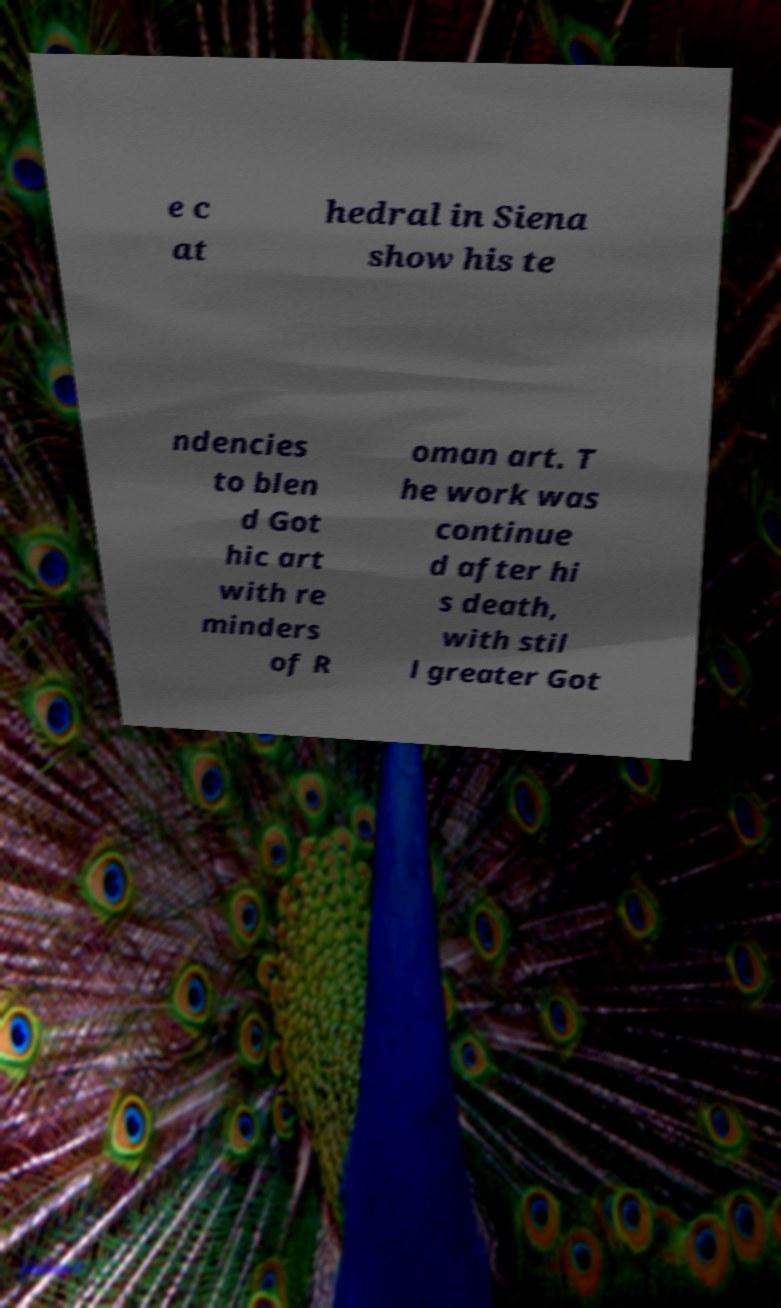Could you assist in decoding the text presented in this image and type it out clearly? e c at hedral in Siena show his te ndencies to blen d Got hic art with re minders of R oman art. T he work was continue d after hi s death, with stil l greater Got 